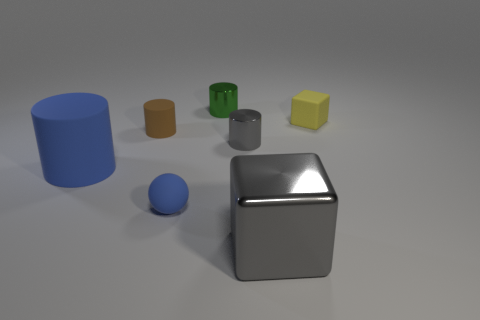The rubber ball that is the same color as the big rubber thing is what size?
Ensure brevity in your answer.  Small. Are there any small things of the same color as the big cylinder?
Provide a short and direct response. Yes. What is the shape of the other small object that is the same material as the green thing?
Offer a terse response. Cylinder. Are any tiny green shiny cylinders visible?
Offer a terse response. Yes. Are there fewer large gray things behind the large rubber object than green cylinders to the left of the tiny gray metallic object?
Ensure brevity in your answer.  Yes. There is a tiny brown matte object that is on the right side of the big blue thing; what shape is it?
Your response must be concise. Cylinder. Is the big block made of the same material as the tiny yellow object?
Offer a terse response. No. There is a green thing that is the same shape as the large blue object; what is its material?
Keep it short and to the point. Metal. Is the number of objects behind the yellow matte thing less than the number of big purple metal balls?
Keep it short and to the point. No. How many small blue balls are in front of the small block?
Your answer should be compact. 1. 